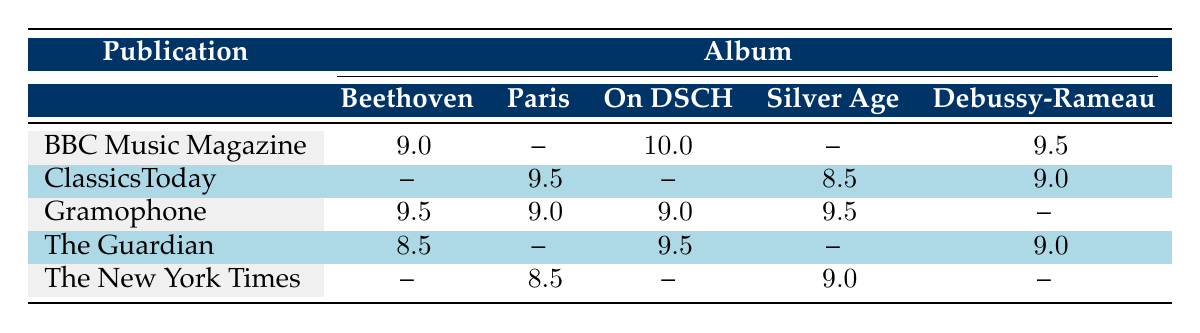What is the highest rating given to an album by BBC Music Magazine? The highest rating given by BBC Music Magazine is 10.0 for the album "Igor Levit: On DSCH." This information can be found by scanning the row under "BBC Music Magazine" and identifying the maximum rating.
Answer: 10.0 Which publication gave a rating of 9.5 to "Daniil Trifonov: Silver Age"? "Daniil Trifonov: Silver Age" received a rating of 9.5 only from Gramophone. I can find this by examining the appropriate column for "Silver Age" and checking the corresponding publications and ratings.
Answer: Gramophone What is the average rating of the albums reviewed by ClassicsToday? The ratings given by ClassicsToday are 9.5, 8.5, 9.0 (for "Paris," "Silver Age," and "Debussy-Rameau," respectively). Adding these ratings gives a total of 27.0, and dividing by 3 results in an average of 9.0.
Answer: 9.0 Did The New York Times give the same rating for “Paris” as it did for "On DSCH"? No, The New York Times rated "Paris" 8.5, while "On DSCH" was not rated at all (indicated by the dash). Hence, the ratings differ significantly.
Answer: No Which album received the most variation in ratings among different publications? "Yannick Nézet-Séguin: Beethoven Symphonies" shows the most variation with ratings of 9.5 from Gramophone, 9.0 from BBC Music Magazine, and 8.5 from The Guardian, leading to a variation of 1.0. I derive this by inspecting the different ratings for albums across publications.
Answer: "Yannick Nézet-Séguin: Beethoven Symphonies" 